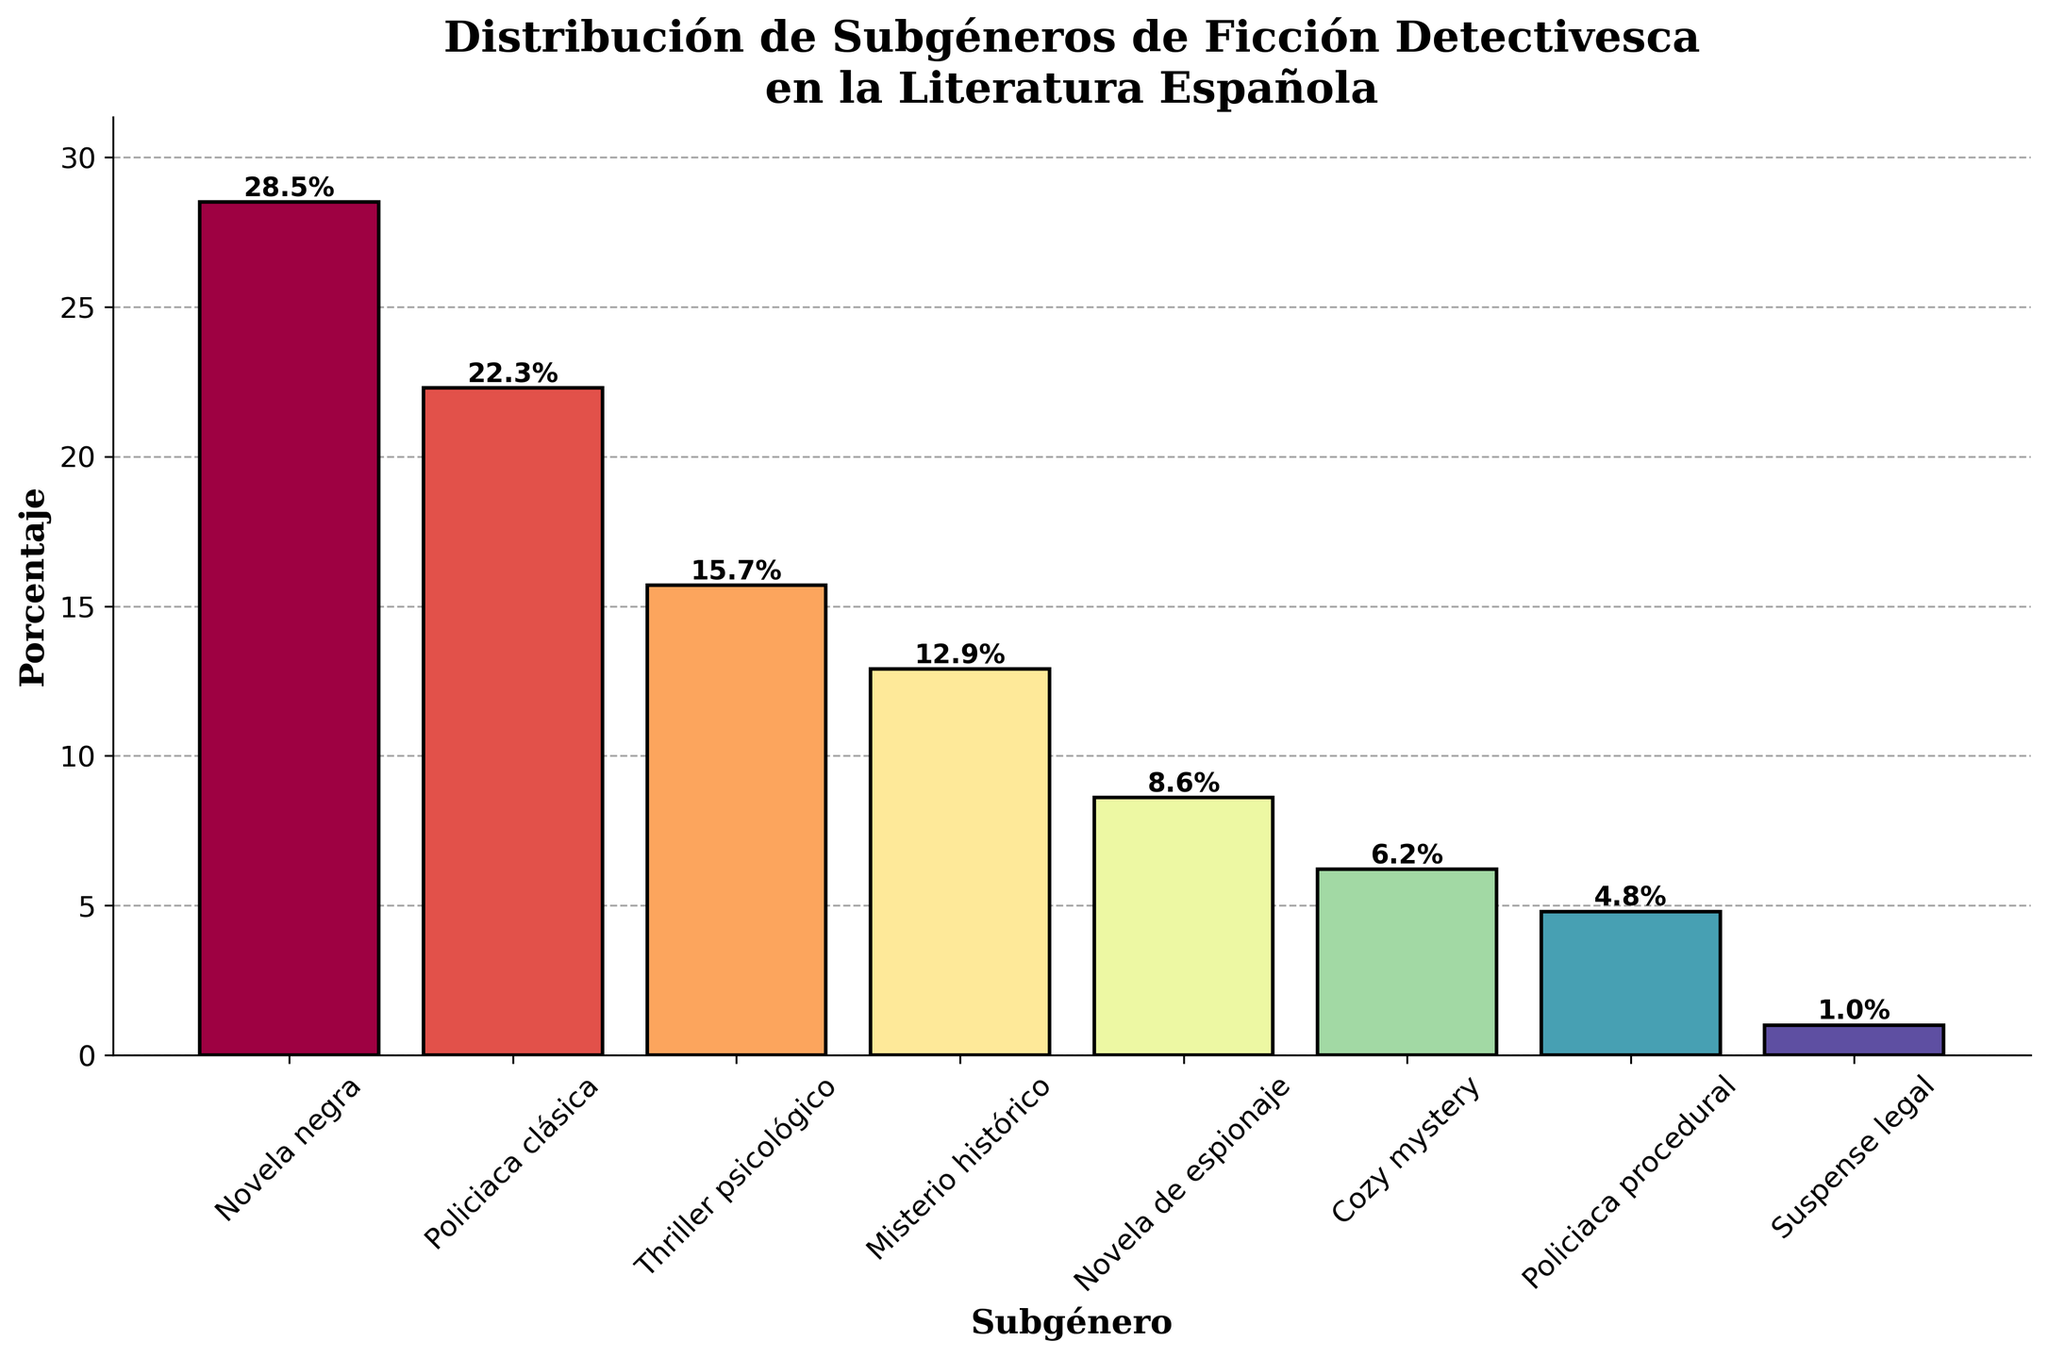What is the most prevalent subgenre of detective fiction in Spanish literature? The bar representing "Novela negra" is the tallest, indicating the highest percentage among the subgenres.
Answer: Novela negra Which subgenre has a higher percentage: "Policiaca clásica" or "Thriller psicológico"? Comparing the heights of the bars, "Policiaca clásica" is taller than "Thriller psicológico".
Answer: Policiaca clásica What is the combined percentage of "Misterio histórico" and "Novela de espionaje"? The percentage for "Misterio histórico" is 12.9% and for "Novela de espionaje" is 8.6%. Adding them together: 12.9% + 8.6% = 21.5%.
Answer: 21.5% Which subgenre has the lowest percentage? The bar for "Suspense legal" is the shortest, indicating it has the lowest percentage.
Answer: Suspense legal How much higher is the percentage of "Novela negra" compared to "Cozy mystery"? The percentage for "Novela negra" is 28.5% and for "Cozy mystery" is 6.2%. Subtracting these: 28.5% - 6.2% = 22.3%.
Answer: 22.3% List the subgenres that have a percentage higher than 10%. The subgenres with bars above the 10% mark are: "Novela negra," "Policiaca clásica," "Thriller psicológico," and "Misterio histórico."
Answer: Novela negra, Policiaca clásica, Thriller psicológico, Misterio histórico By what percentage does "Policiaca procedural" fall behind "Thriller psicológico"? The percentage for "Thriller psicológico" is 15.7% and for "Policiaca procedural" is 4.8%. Subtracting these: 15.7% - 4.8% = 10.9%.
Answer: 10.9% Which subgenre has a percentage closest to 20%? The bar for "Policiaca clásica" is closest to the 20% mark, with 22.3%.
Answer: Policiaca clásica Which two adjacent subgenres have the smallest difference in percentage? The smallest difference is between "Novela de espionaje" (8.6%) and "Cozy mystery" (6.2%), with a difference of 8.6% - 6.2% = 2.4%.
Answer: Novela de espionaje and Cozy mystery 